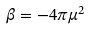Convert formula to latex. <formula><loc_0><loc_0><loc_500><loc_500>\beta = - 4 \pi \mu ^ { 2 }</formula> 